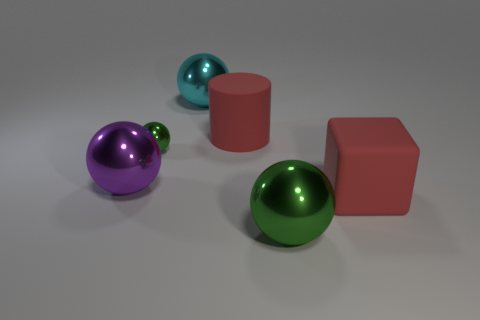There is a big metallic object that is behind the big green metal object and on the right side of the purple thing; what shape is it? sphere 